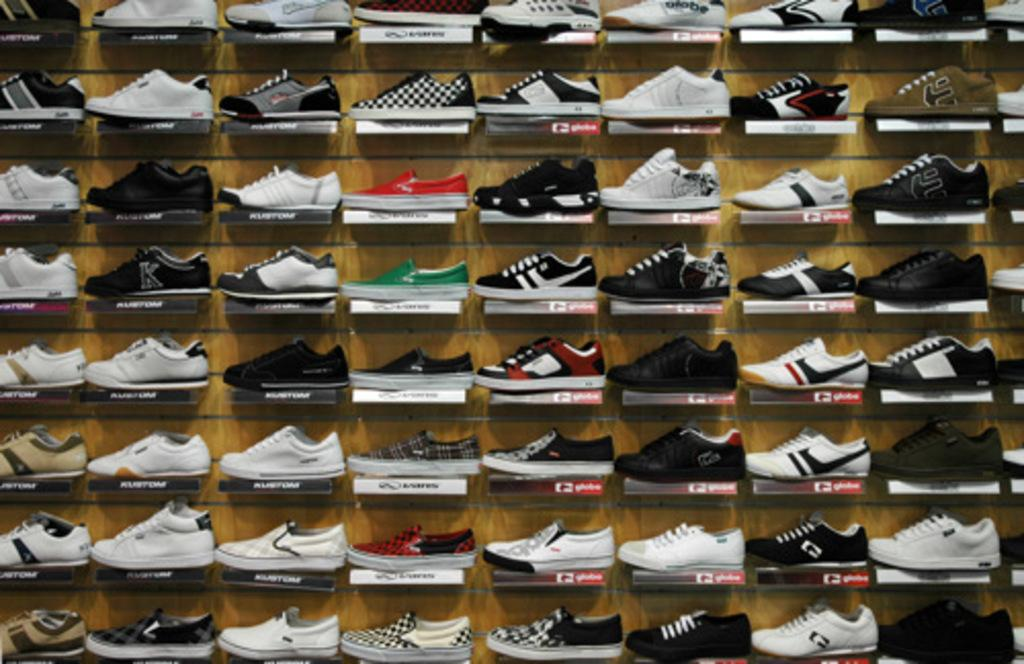What objects are on the racks in the image? There are shoes on racks in the image. What can be seen on the racks besides the shoes? There is writing on each rack. What type of cheese is being stored on the racks in the image? There is no cheese present in the image; it features shoes on racks with writing on each rack. Can you see a squirrel interacting with the with the shoes on the racks in the image? There is no squirrel present in the image; it only features shoes on racks with writing on each rack. 